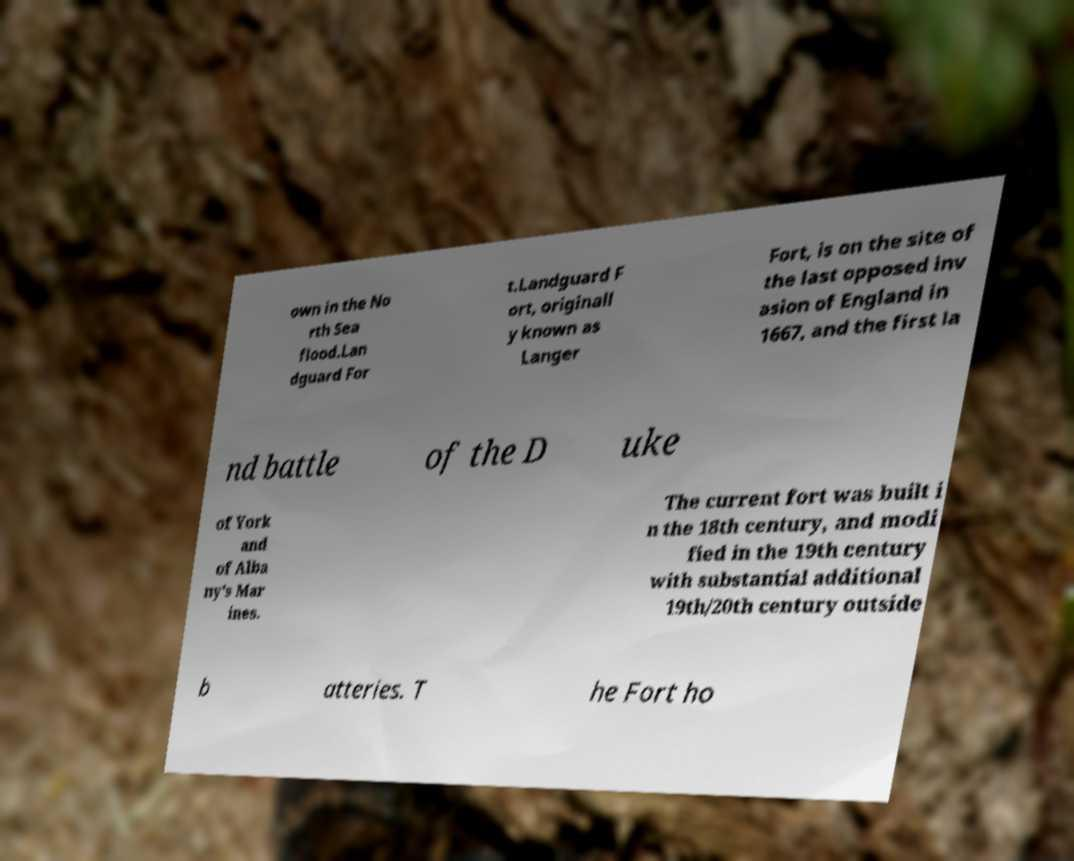What messages or text are displayed in this image? I need them in a readable, typed format. own in the No rth Sea flood.Lan dguard For t.Landguard F ort, originall y known as Langer Fort, is on the site of the last opposed inv asion of England in 1667, and the first la nd battle of the D uke of York and of Alba ny's Mar ines. The current fort was built i n the 18th century, and modi fied in the 19th century with substantial additional 19th/20th century outside b atteries. T he Fort ho 